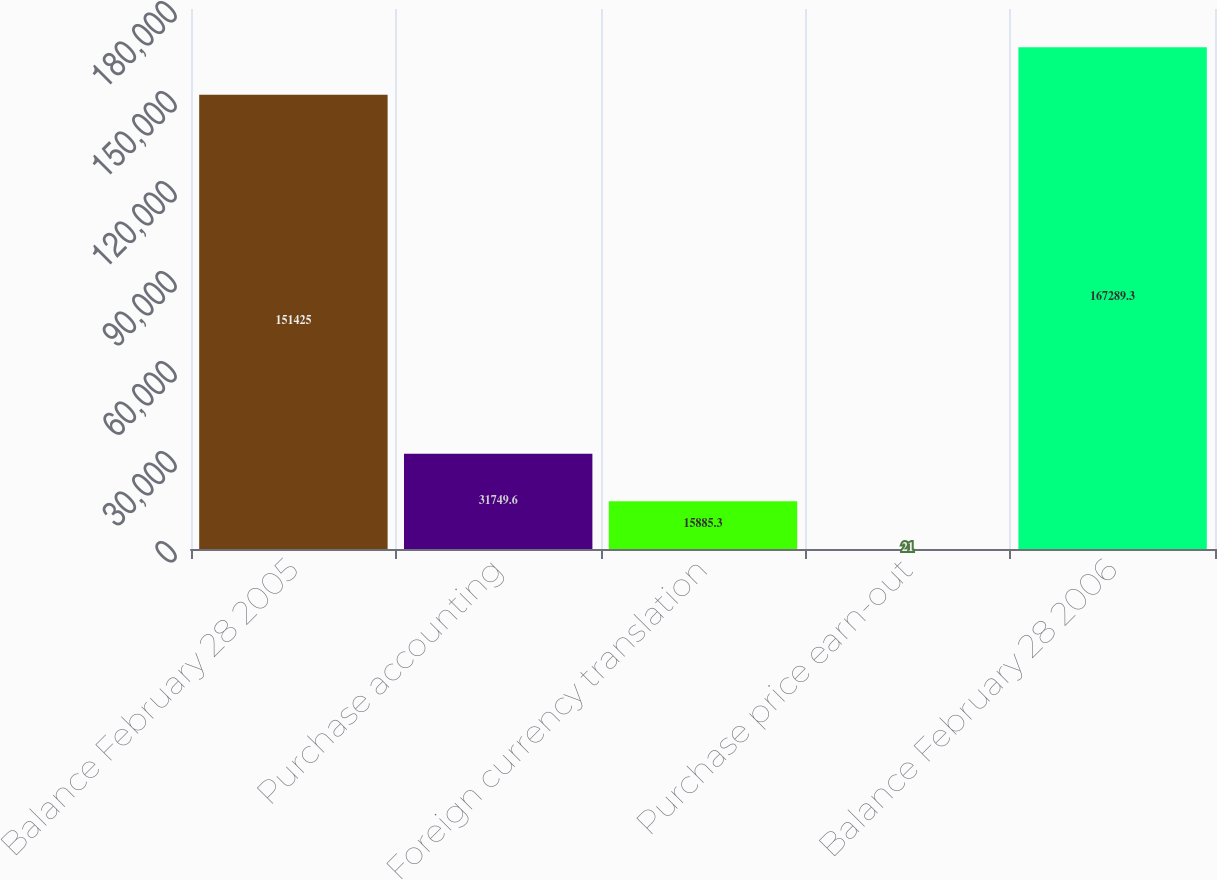Convert chart. <chart><loc_0><loc_0><loc_500><loc_500><bar_chart><fcel>Balance February 28 2005<fcel>Purchase accounting<fcel>Foreign currency translation<fcel>Purchase price earn-out<fcel>Balance February 28 2006<nl><fcel>151425<fcel>31749.6<fcel>15885.3<fcel>21<fcel>167289<nl></chart> 